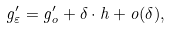Convert formula to latex. <formula><loc_0><loc_0><loc_500><loc_500>g _ { \varepsilon } ^ { \prime } = g _ { o } ^ { \prime } + \delta \cdot h + o ( \delta ) ,</formula> 